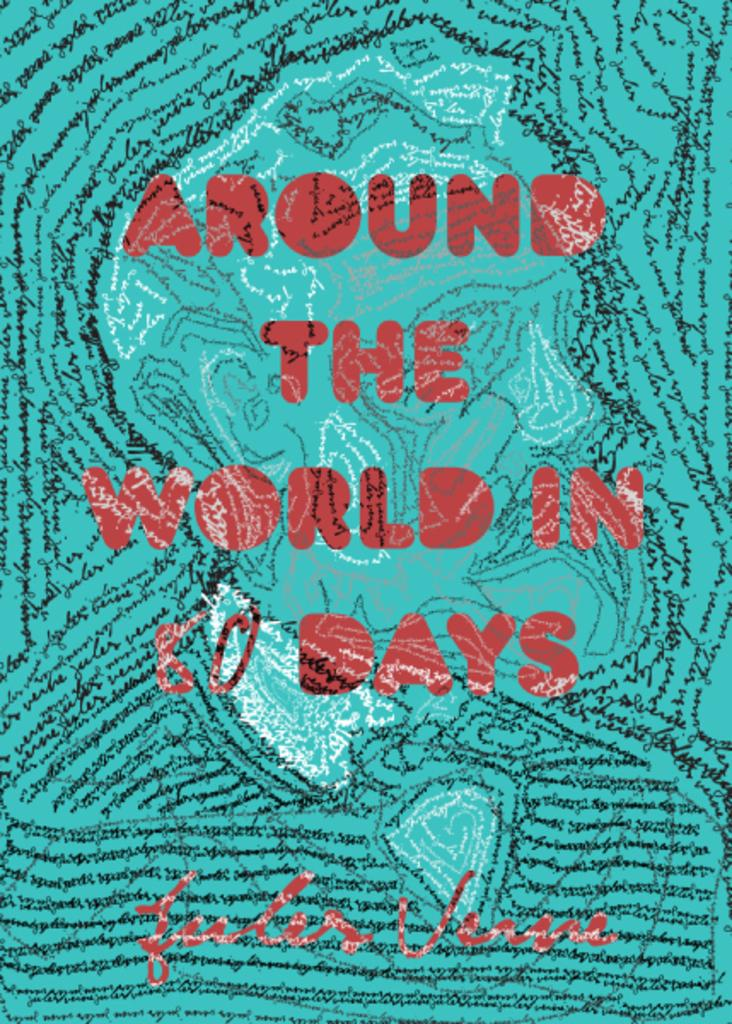Provide a one-sentence caption for the provided image. Turquoise book cover from a book called "Around The World in 80 Days". 